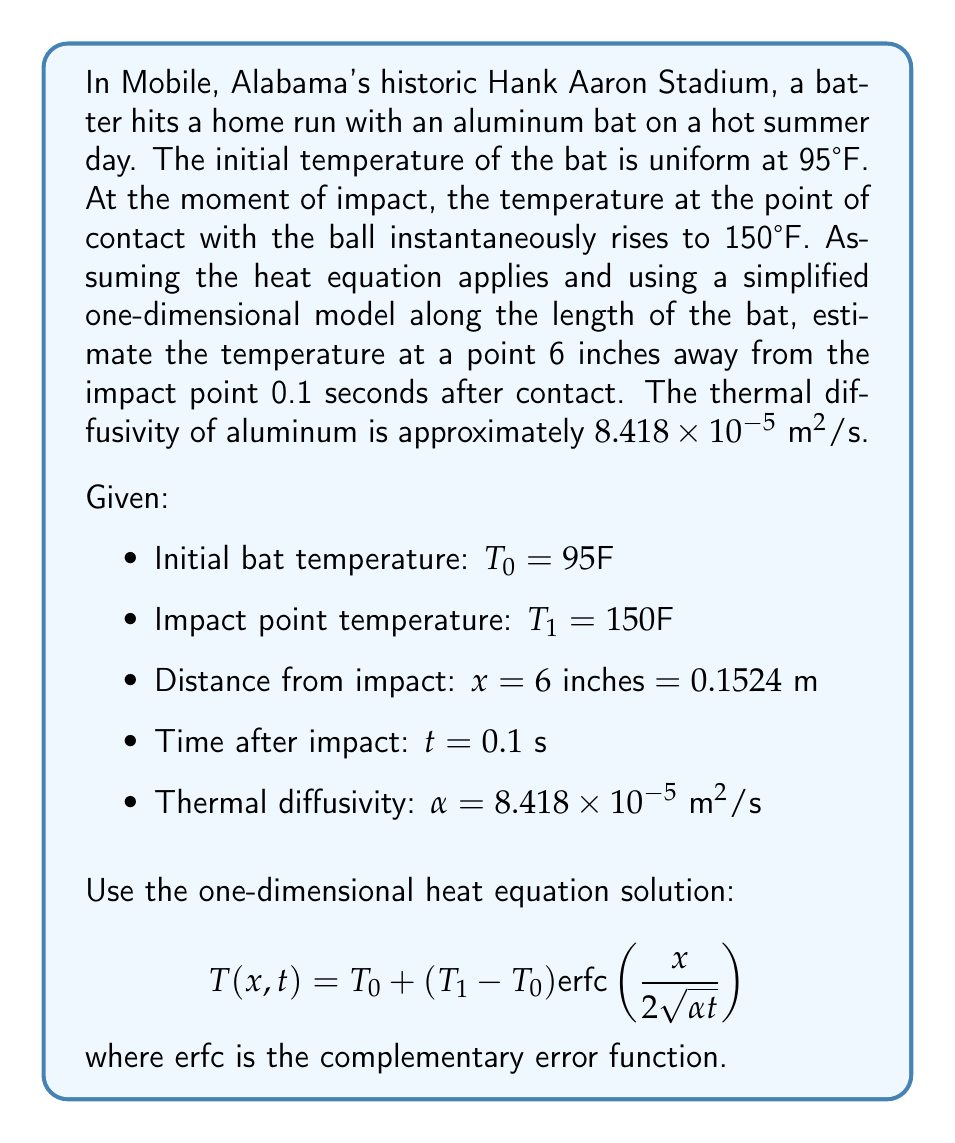Help me with this question. To solve this problem, we'll follow these steps:

1) First, let's identify our known values:
   $T_0 = 95°\text{F}$
   $T_1 = 150°\text{F}$
   $x = 0.1524 \text{ m}$
   $t = 0.1 \text{ s}$
   $\alpha = 8.418 \times 10^{-5} \text{ m}^2/\text{s}$

2) Now, we'll calculate the argument of the complementary error function:

   $$\frac{x}{2\sqrt{\alpha t}} = \frac{0.1524}{2\sqrt{(8.418 \times 10^{-5})(0.1)}} \approx 2.6213$$

3) We need to find $\text{erfc}(2.6213)$. This can be looked up in a table or calculated using a scientific calculator or computer software. The value is approximately:

   $\text{erfc}(2.6213) \approx 0.0012$

4) Now we can plug everything into our equation:

   $$T(x,t) = T_0 + (T_1 - T_0) \text{erfc}\left(\frac{x}{2\sqrt{\alpha t}}\right)$$
   $$T(0.1524, 0.1) = 95 + (150 - 95)(0.0012)$$
   $$T(0.1524, 0.1) = 95 + 55(0.0012)$$
   $$T(0.1524, 0.1) = 95 + 0.066$$
   $$T(0.1524, 0.1) = 95.066°\text{F}$$

5) Rounding to the nearest tenth of a degree:

   $$T(0.1524, 0.1) \approx 95.1°\text{F}$$
Answer: The temperature at a point 6 inches away from the impact point 0.1 seconds after contact is approximately 95.1°F. 